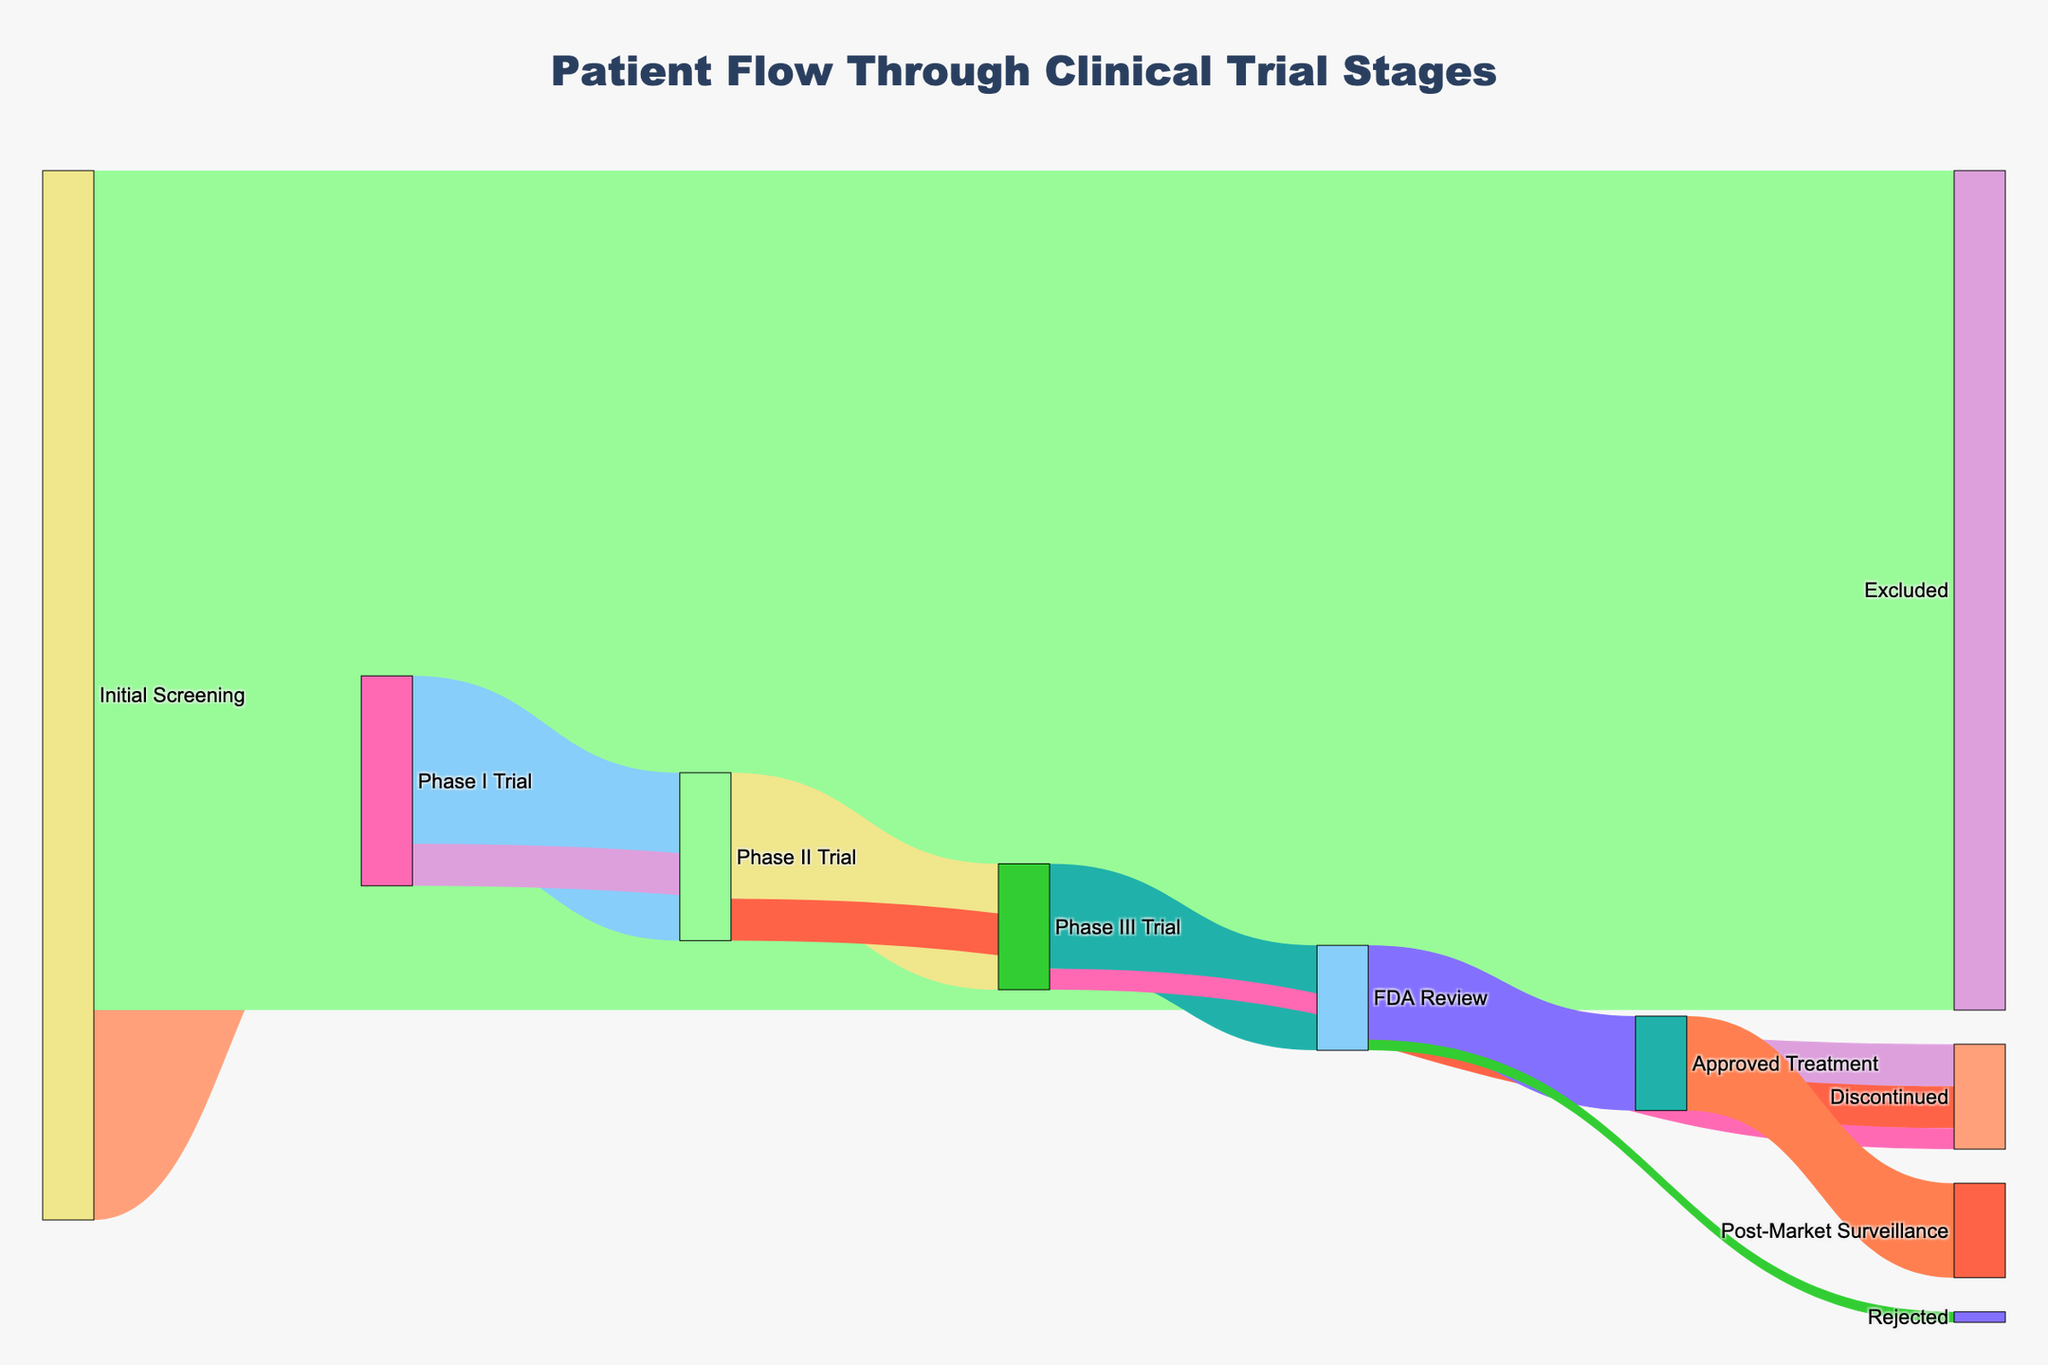what is the title of the figure? The title of the figure is prominently displayed at the top and is labeled as "Patient Flow Through Clinical Trial Stages". To find the title, look at the topmost part of the figure.
Answer: Patient Flow Through Clinical Trial Stages how many patients moved from Initial Screening to Phase I Trial? Look for the link connecting "Initial Screening" to "Phase I Trial". The value associated with this link is 1000, which indicates that 1000 patients moved to Phase I.
Answer: 1000 how many patients were excluded at the Initial Screening stage? Identify the link from "Initial Screening" to "Excluded". The value on this link is 4000, so 4000 patients were excluded.
Answer: 4000 which phase had the most patients discontinue participation? Compare the discontinuation values at each phase: 200 in Phase I, 200 in Phase II, and 100 in Phase III. Both Phase I and Phase II had the most patients discontinue, each with 200 patients.
Answer: Phase I and Phase II how many patients were approved for the treatment after FDA Review? Find the link from "FDA Review" to "Approved Treatment" and look at the value on this link, which is 450. Therefore, 450 patients were approved.
Answer: 450 how many patients reached Phase III Trial from Phase II Trial? Trace the link from "Phase II Trial" to "Phase III Trial". The value for this link is 600, indicating that 600 patients progressed to Phase III.
Answer: 600 how many patients were in FDA Review, and what percentage were approved? Add the values entering FDA Review: 500. From these, 450 were approved, so the percentage is (450/500)*100 = 90%.
Answer: 500, 90% compare the number of patients who transitioned from Phase III Trial to FDA Review with those who were rejected by the FDA From the figure, 500 transitioned from Phase III to FDA Review, and 50 were rejected by the FDA. This shows that significantly more patients transitioned to review than were rejected.
Answer: 500 and 50 what is the total number of patients that discontinued from any phase? Sum the discontinuation values: 200 (Phase I) + 200 (Phase II) + 100 (Phase III) = 500. Therefore, 500 patients discontinued.
Answer: 500 which phase saw the largest drop-off in patient numbers? Compare the drop-offs: Initial Screening to Excluded (4000), Phase I to Discontinued (200), Phase II to Discontinued (200), Phase III to Discontinued (100). The largest drop-off was at the Initial Screening to Excluded (4000).
Answer: Initial Screening to Excluded 